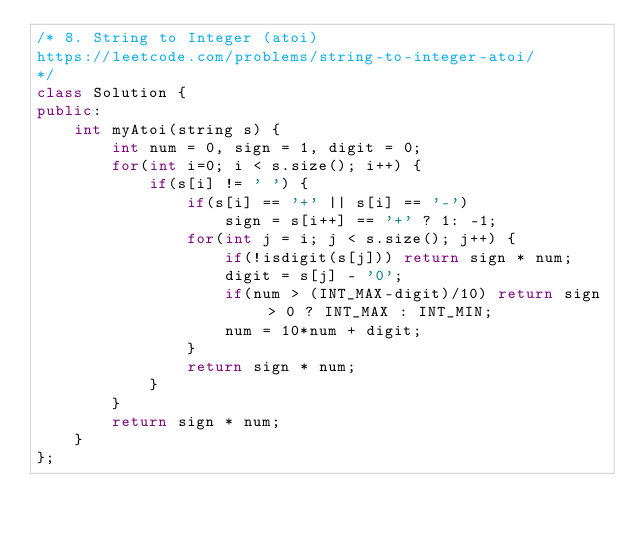Convert code to text. <code><loc_0><loc_0><loc_500><loc_500><_C++_>/* 8. String to Integer (atoi)
https://leetcode.com/problems/string-to-integer-atoi/
*/
class Solution {
public:
    int myAtoi(string s) {
        int num = 0, sign = 1, digit = 0;
        for(int i=0; i < s.size(); i++) {
            if(s[i] != ' ') {
                if(s[i] == '+' || s[i] == '-')
                    sign = s[i++] == '+' ? 1: -1;
                for(int j = i; j < s.size(); j++) {
                    if(!isdigit(s[j])) return sign * num;
                    digit = s[j] - '0';
                    if(num > (INT_MAX-digit)/10) return sign > 0 ? INT_MAX : INT_MIN;
                    num = 10*num + digit;
                }
                return sign * num;
            }
        }
        return sign * num;
    }
};</code> 